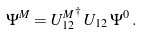Convert formula to latex. <formula><loc_0><loc_0><loc_500><loc_500>\Psi ^ { M } = { U ^ { M } _ { 1 2 } } ^ { \dagger } \, U _ { 1 2 } \, \Psi ^ { 0 } \, .</formula> 